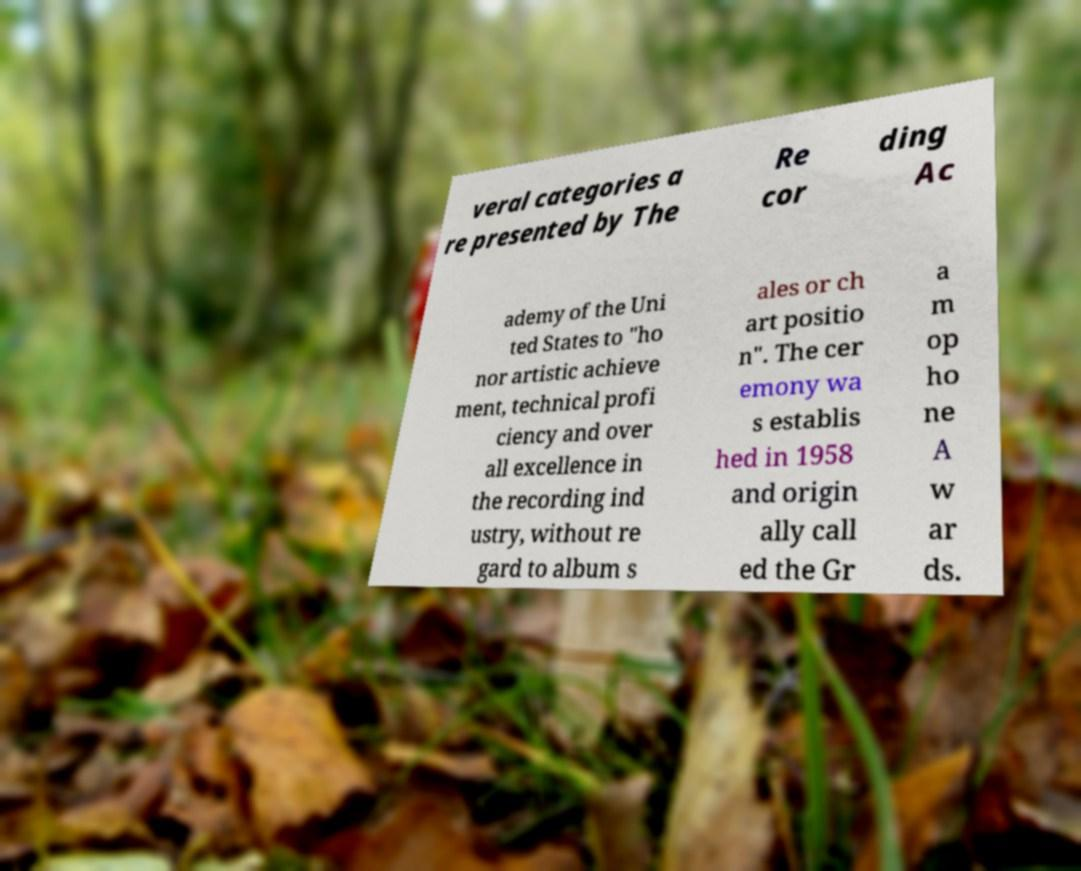Could you extract and type out the text from this image? veral categories a re presented by The Re cor ding Ac ademy of the Uni ted States to "ho nor artistic achieve ment, technical profi ciency and over all excellence in the recording ind ustry, without re gard to album s ales or ch art positio n". The cer emony wa s establis hed in 1958 and origin ally call ed the Gr a m op ho ne A w ar ds. 